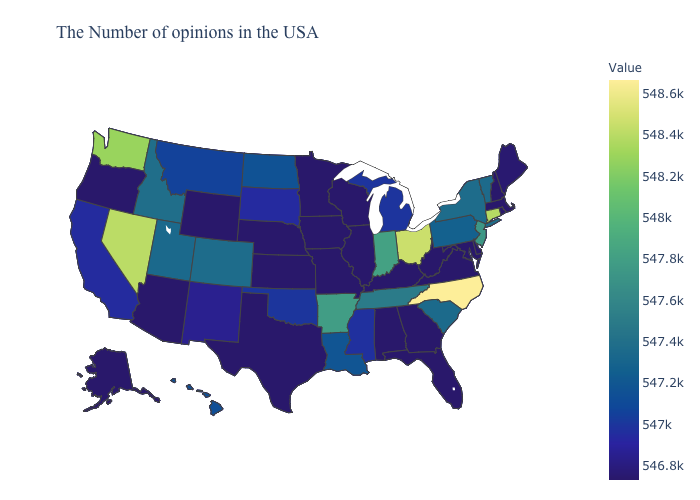Among the states that border New Jersey , which have the lowest value?
Quick response, please. Delaware. Among the states that border Kansas , does Colorado have the lowest value?
Short answer required. No. Which states hav the highest value in the South?
Give a very brief answer. North Carolina. Among the states that border North Carolina , which have the lowest value?
Keep it brief. Virginia, Georgia. Does North Carolina have the highest value in the USA?
Concise answer only. Yes. 